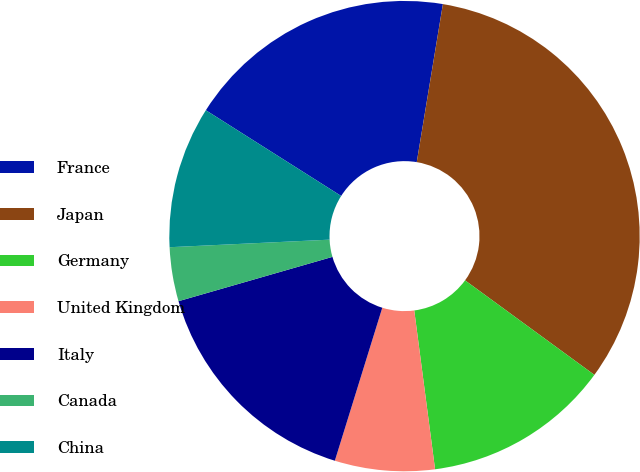Convert chart. <chart><loc_0><loc_0><loc_500><loc_500><pie_chart><fcel>France<fcel>Japan<fcel>Germany<fcel>United Kingdom<fcel>Italy<fcel>Canada<fcel>China<nl><fcel>18.62%<fcel>32.43%<fcel>12.88%<fcel>6.86%<fcel>15.75%<fcel>3.71%<fcel>9.74%<nl></chart> 